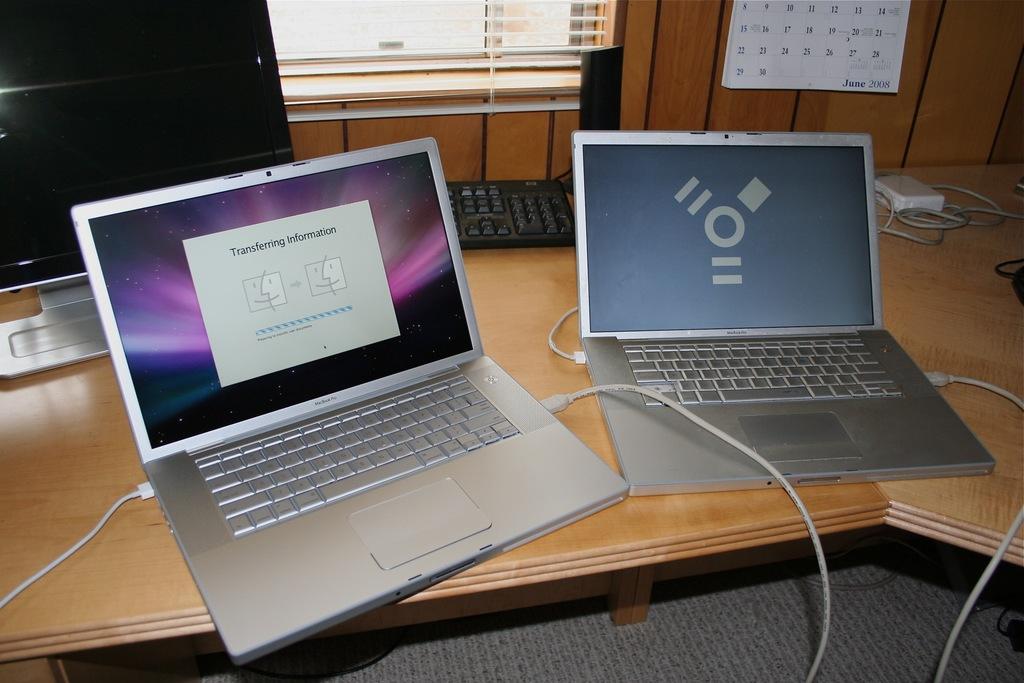What is the computer doing?
Offer a terse response. Transferring information. 